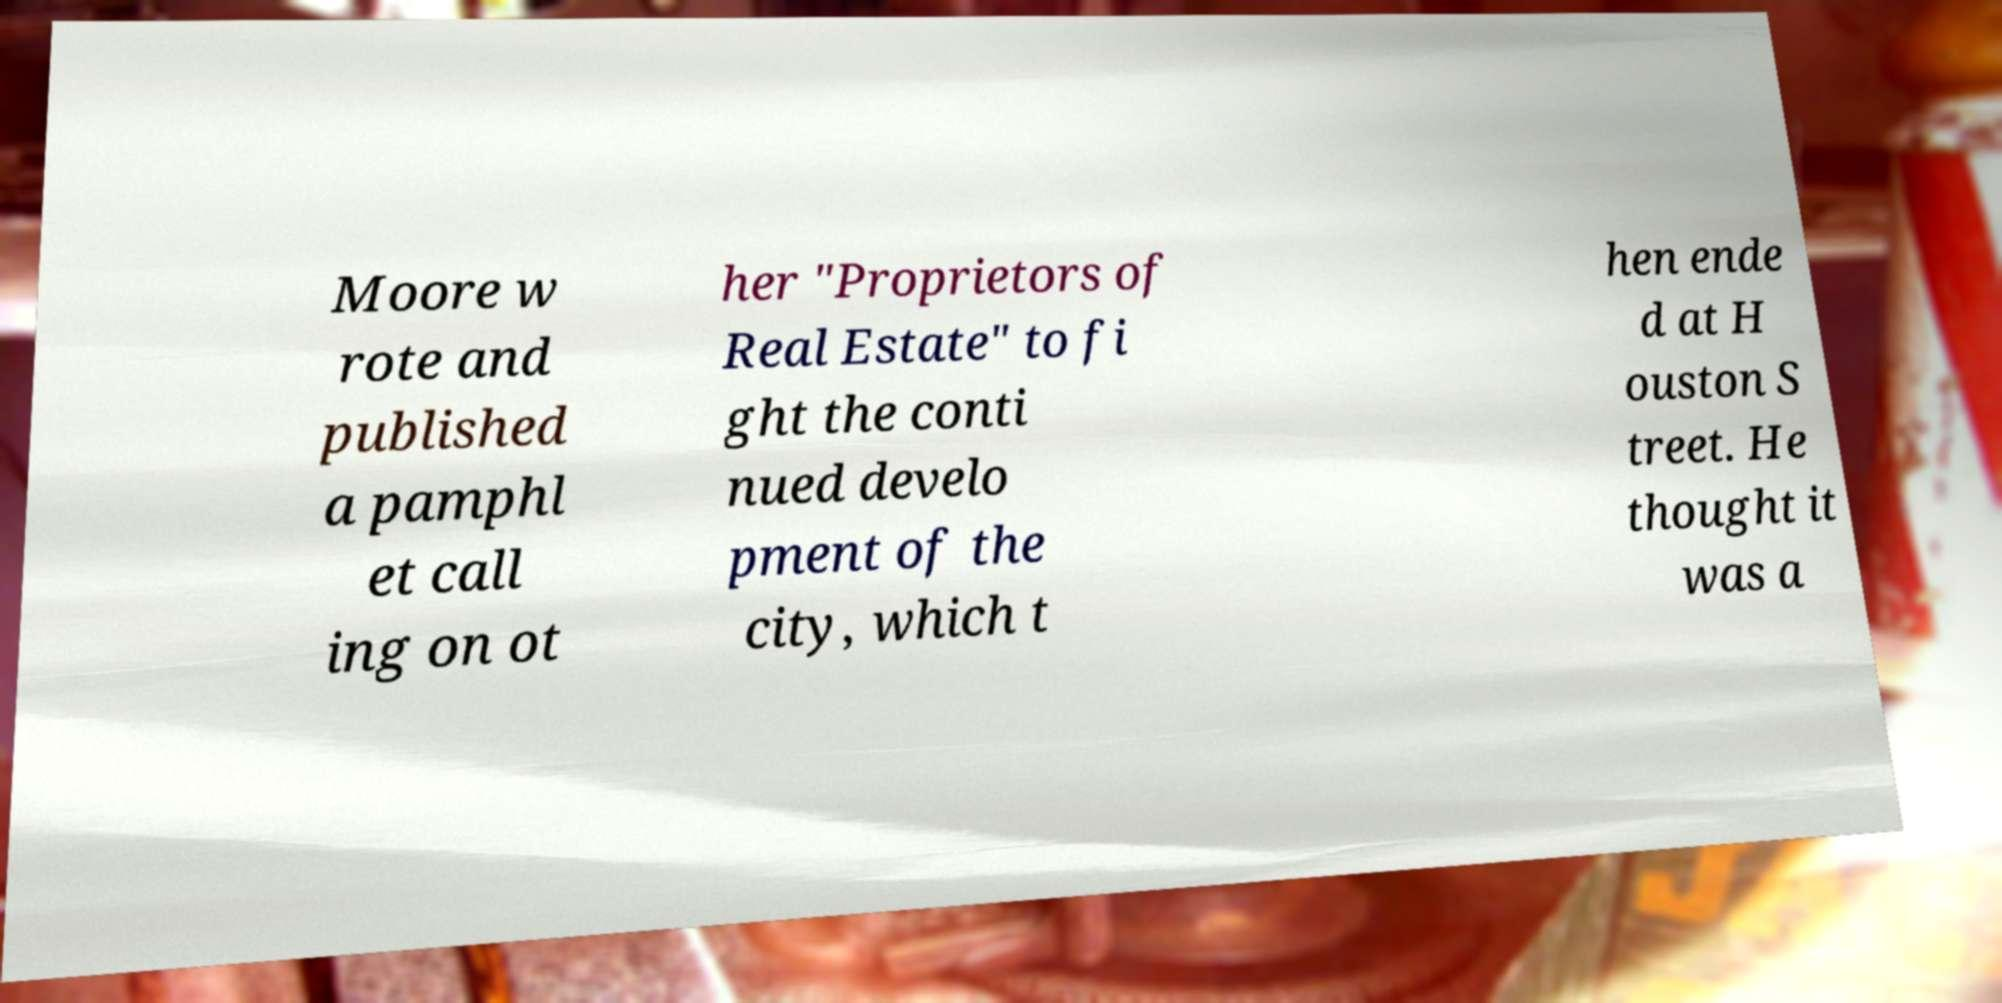Please read and relay the text visible in this image. What does it say? Moore w rote and published a pamphl et call ing on ot her "Proprietors of Real Estate" to fi ght the conti nued develo pment of the city, which t hen ende d at H ouston S treet. He thought it was a 